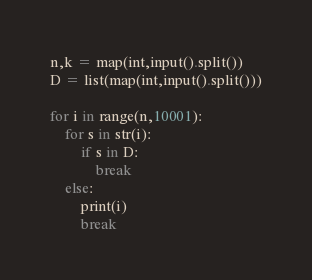<code> <loc_0><loc_0><loc_500><loc_500><_Python_>n,k = map(int,input().split())
D = list(map(int,input().split()))

for i in range(n,10001):
    for s in str(i):
        if s in D:
            break
    else:
        print(i)
        break</code> 